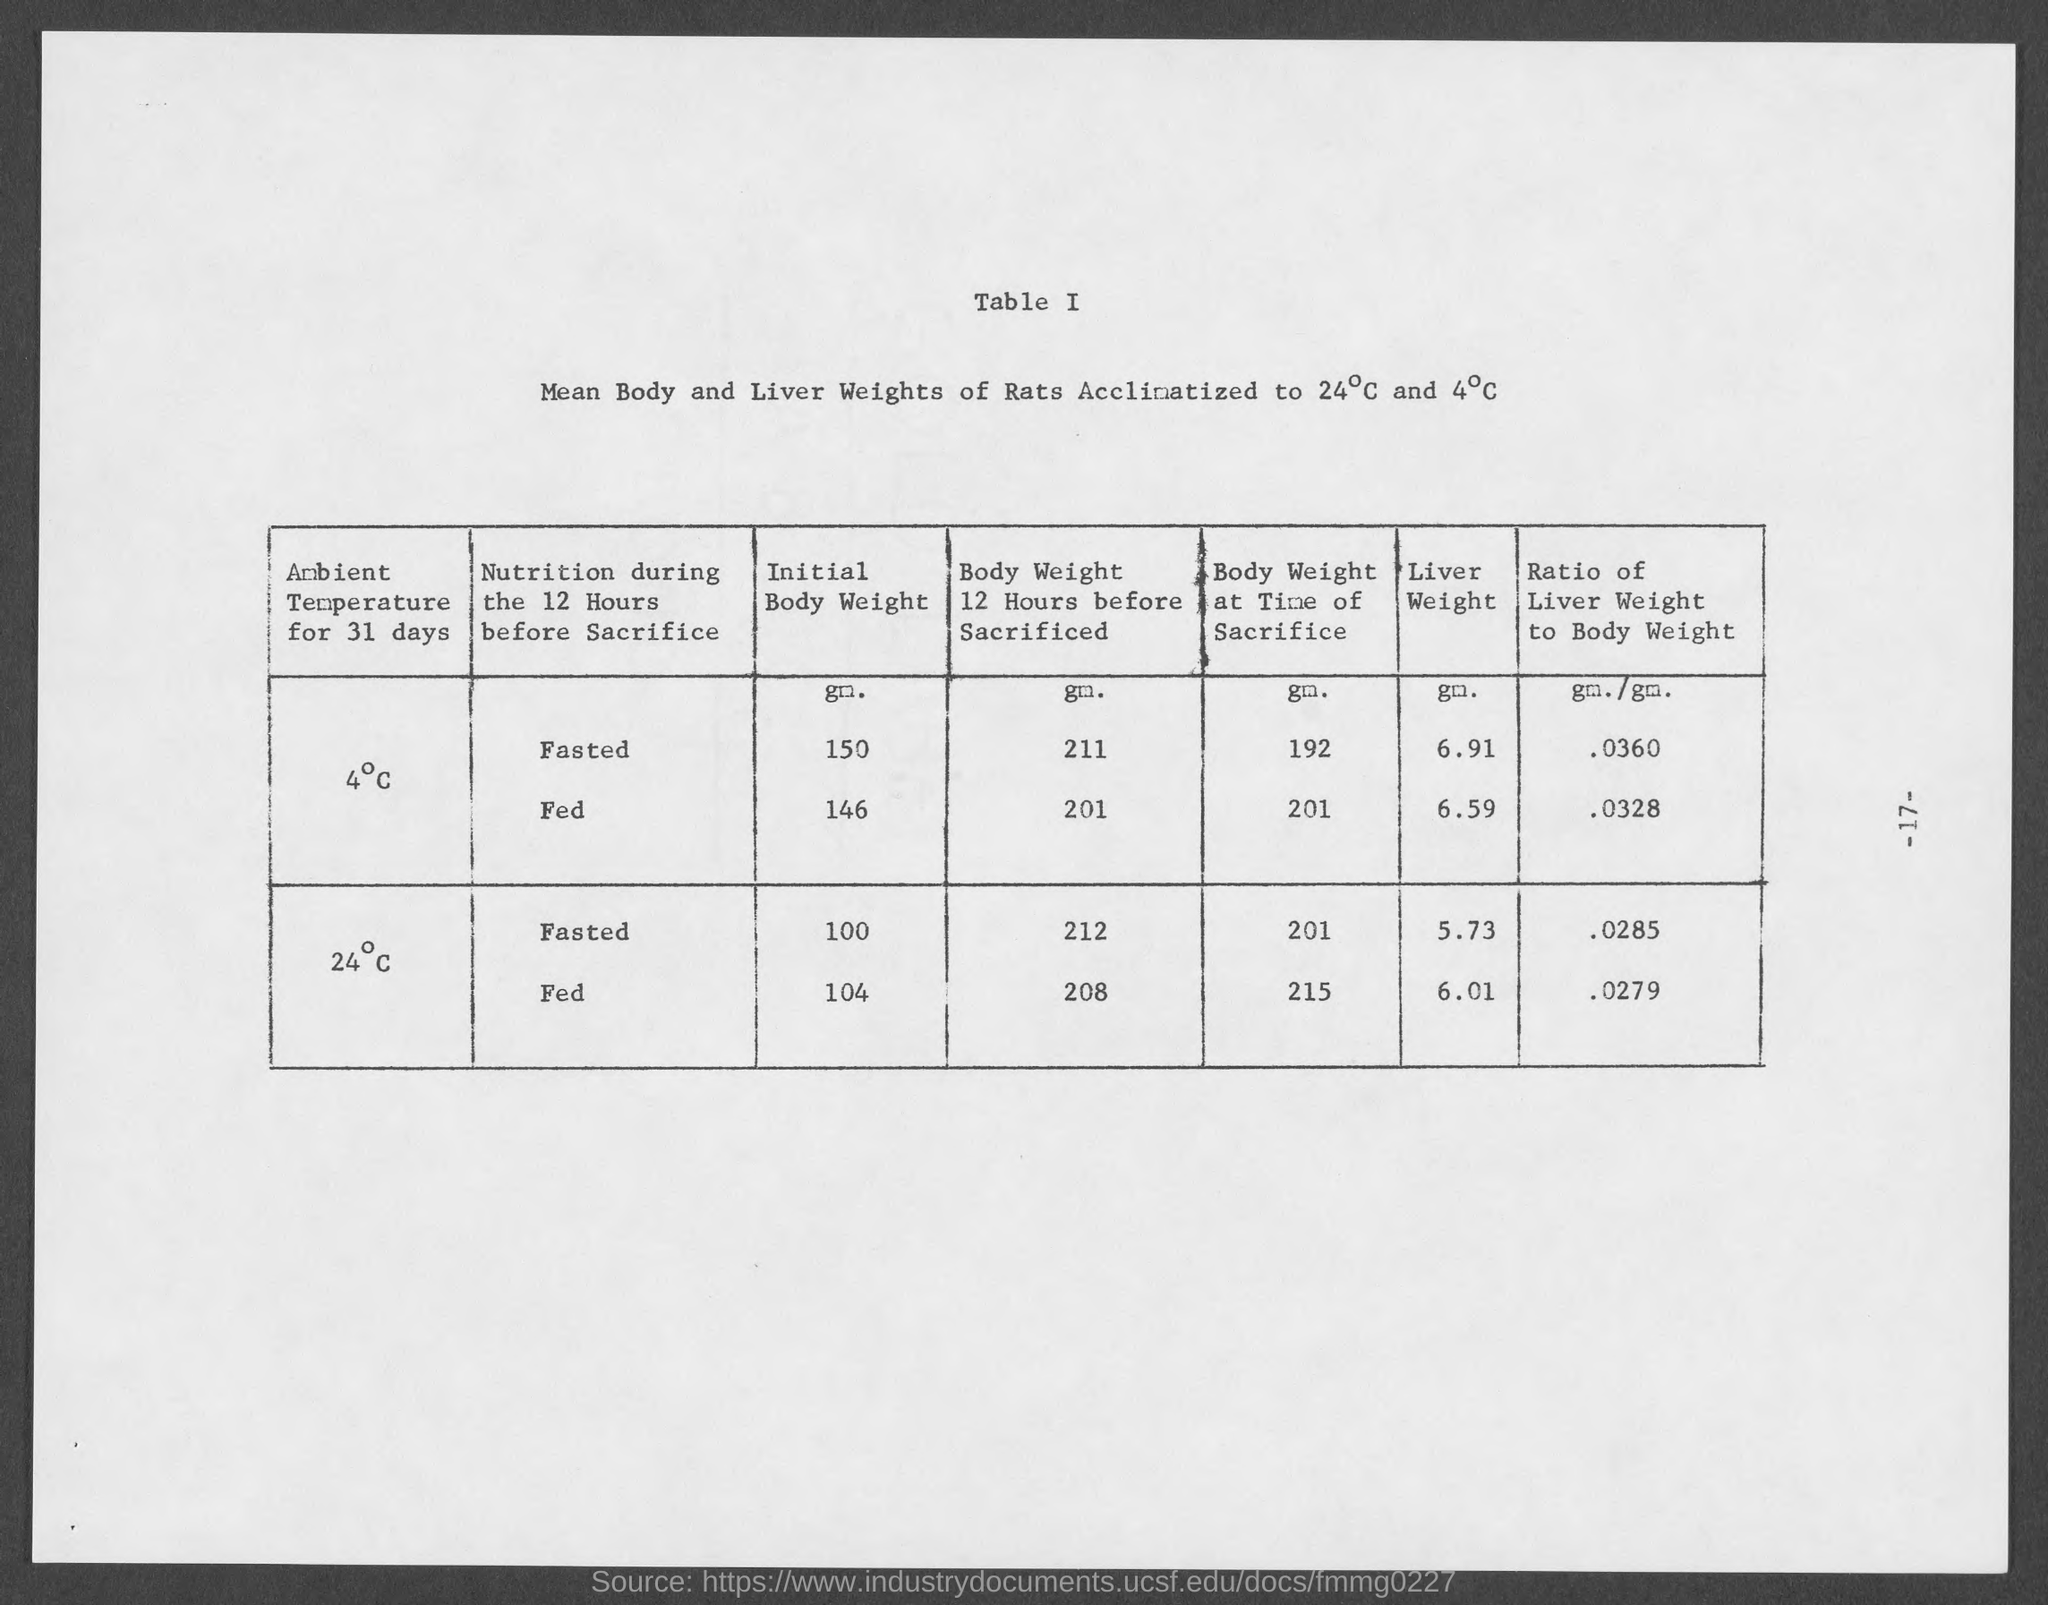How much is the liver weight of fasted rats acclimatised to 24 degree Celsius?
Provide a succinct answer. 5.73. 